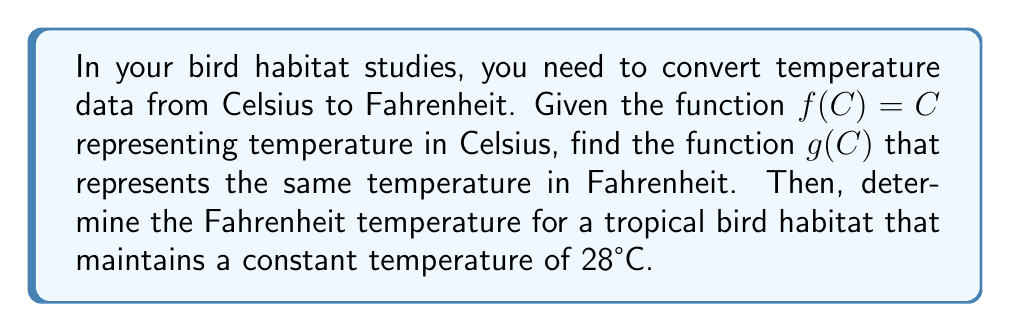What is the answer to this math problem? 1) The formula to convert Celsius to Fahrenheit is:
   $F = \frac{9}{5}C + 32$

2) To create the function $g(C)$, we apply this transformation to $f(C)$:
   $g(C) = \frac{9}{5}f(C) + 32$

3) Since $f(C) = C$, we can substitute:
   $g(C) = \frac{9}{5}C + 32$

4) This is our transformed function that converts Celsius to Fahrenheit.

5) To find the Fahrenheit temperature for 28°C, we evaluate $g(28)$:
   $g(28) = \frac{9}{5}(28) + 32$
   $= \frac{252}{5} + 32$
   $= 50.4 + 32$
   $= 82.4$

Therefore, 28°C is equivalent to 82.4°F in the tropical bird habitat.
Answer: $g(C) = \frac{9}{5}C + 32$; 82.4°F 